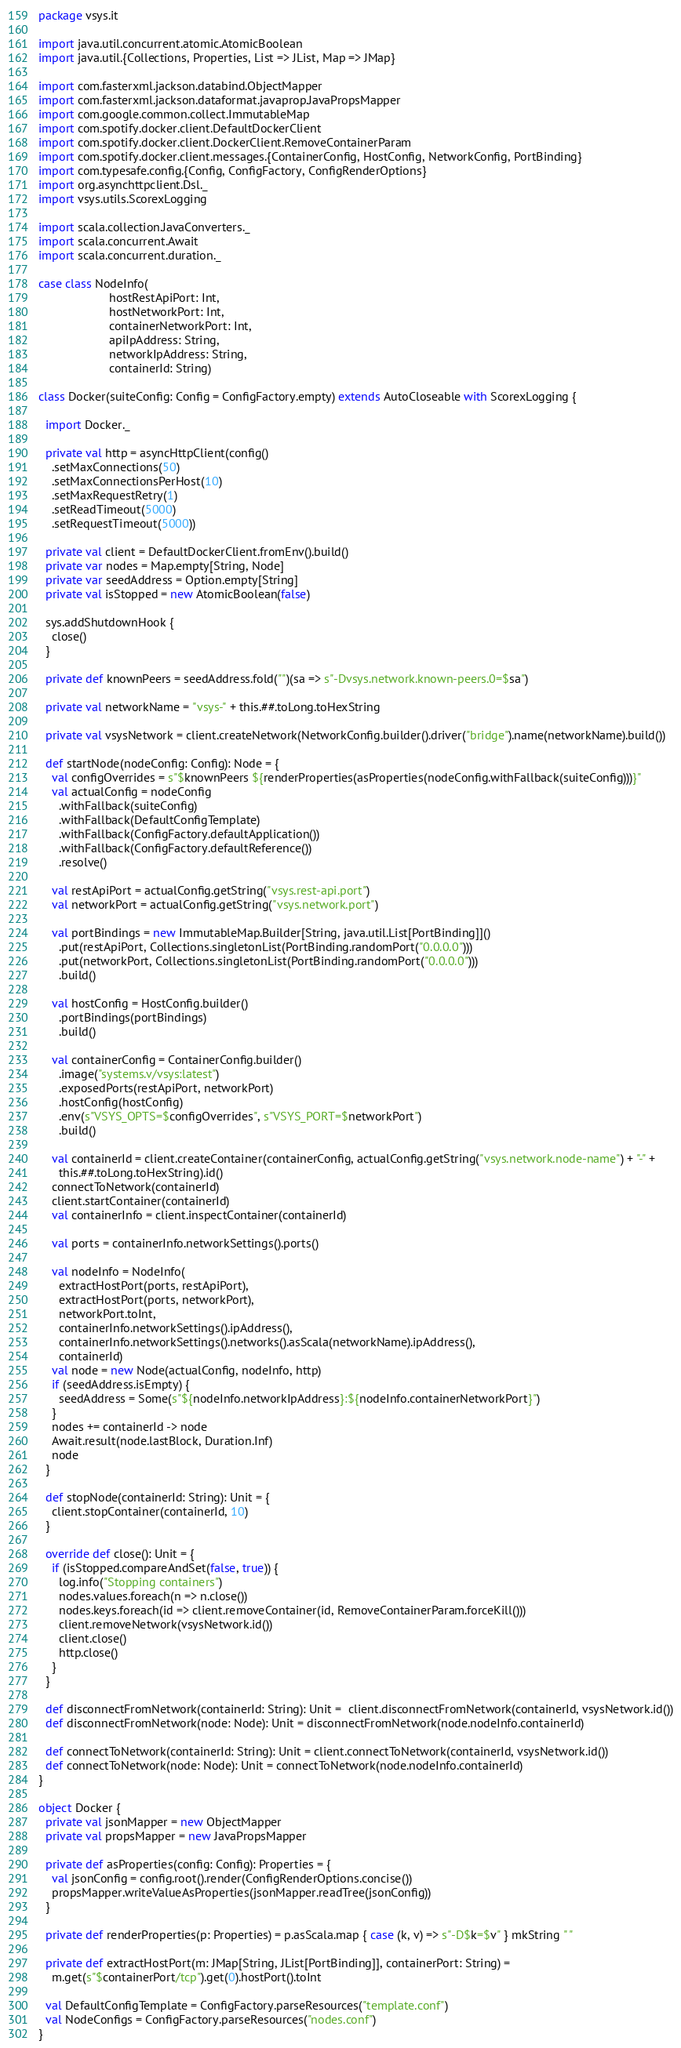Convert code to text. <code><loc_0><loc_0><loc_500><loc_500><_Scala_>package vsys.it

import java.util.concurrent.atomic.AtomicBoolean
import java.util.{Collections, Properties, List => JList, Map => JMap}

import com.fasterxml.jackson.databind.ObjectMapper
import com.fasterxml.jackson.dataformat.javaprop.JavaPropsMapper
import com.google.common.collect.ImmutableMap
import com.spotify.docker.client.DefaultDockerClient
import com.spotify.docker.client.DockerClient.RemoveContainerParam
import com.spotify.docker.client.messages.{ContainerConfig, HostConfig, NetworkConfig, PortBinding}
import com.typesafe.config.{Config, ConfigFactory, ConfigRenderOptions}
import org.asynchttpclient.Dsl._
import vsys.utils.ScorexLogging

import scala.collection.JavaConverters._
import scala.concurrent.Await
import scala.concurrent.duration._

case class NodeInfo(
                     hostRestApiPort: Int,
                     hostNetworkPort: Int,
                     containerNetworkPort: Int,
                     apiIpAddress: String,
                     networkIpAddress: String,
                     containerId: String)

class Docker(suiteConfig: Config = ConfigFactory.empty) extends AutoCloseable with ScorexLogging {

  import Docker._

  private val http = asyncHttpClient(config()
    .setMaxConnections(50)
    .setMaxConnectionsPerHost(10)
    .setMaxRequestRetry(1)
    .setReadTimeout(5000)
    .setRequestTimeout(5000))

  private val client = DefaultDockerClient.fromEnv().build()
  private var nodes = Map.empty[String, Node]
  private var seedAddress = Option.empty[String]
  private val isStopped = new AtomicBoolean(false)

  sys.addShutdownHook {
    close()
  }

  private def knownPeers = seedAddress.fold("")(sa => s"-Dvsys.network.known-peers.0=$sa")

  private val networkName = "vsys-" + this.##.toLong.toHexString

  private val vsysNetwork = client.createNetwork(NetworkConfig.builder().driver("bridge").name(networkName).build())

  def startNode(nodeConfig: Config): Node = {
    val configOverrides = s"$knownPeers ${renderProperties(asProperties(nodeConfig.withFallback(suiteConfig)))}"
    val actualConfig = nodeConfig
      .withFallback(suiteConfig)
      .withFallback(DefaultConfigTemplate)
      .withFallback(ConfigFactory.defaultApplication())
      .withFallback(ConfigFactory.defaultReference())
      .resolve()

    val restApiPort = actualConfig.getString("vsys.rest-api.port")
    val networkPort = actualConfig.getString("vsys.network.port")

    val portBindings = new ImmutableMap.Builder[String, java.util.List[PortBinding]]()
      .put(restApiPort, Collections.singletonList(PortBinding.randomPort("0.0.0.0")))
      .put(networkPort, Collections.singletonList(PortBinding.randomPort("0.0.0.0")))
      .build()

    val hostConfig = HostConfig.builder()
      .portBindings(portBindings)
      .build()

    val containerConfig = ContainerConfig.builder()
      .image("systems.v/vsys:latest")
      .exposedPorts(restApiPort, networkPort)
      .hostConfig(hostConfig)
      .env(s"VSYS_OPTS=$configOverrides", s"VSYS_PORT=$networkPort")
      .build()

    val containerId = client.createContainer(containerConfig, actualConfig.getString("vsys.network.node-name") + "-" +
      this.##.toLong.toHexString).id()
    connectToNetwork(containerId)
    client.startContainer(containerId)
    val containerInfo = client.inspectContainer(containerId)

    val ports = containerInfo.networkSettings().ports()

    val nodeInfo = NodeInfo(
      extractHostPort(ports, restApiPort),
      extractHostPort(ports, networkPort),
      networkPort.toInt,
      containerInfo.networkSettings().ipAddress(),
      containerInfo.networkSettings().networks().asScala(networkName).ipAddress(),
      containerId)
    val node = new Node(actualConfig, nodeInfo, http)
    if (seedAddress.isEmpty) {
      seedAddress = Some(s"${nodeInfo.networkIpAddress}:${nodeInfo.containerNetworkPort}")
    }
    nodes += containerId -> node
    Await.result(node.lastBlock, Duration.Inf)
    node
  }

  def stopNode(containerId: String): Unit = {
    client.stopContainer(containerId, 10)
  }

  override def close(): Unit = {
    if (isStopped.compareAndSet(false, true)) {
      log.info("Stopping containers")
      nodes.values.foreach(n => n.close())
      nodes.keys.foreach(id => client.removeContainer(id, RemoveContainerParam.forceKill()))
      client.removeNetwork(vsysNetwork.id())
      client.close()
      http.close()
    }
  }

  def disconnectFromNetwork(containerId: String): Unit =  client.disconnectFromNetwork(containerId, vsysNetwork.id())
  def disconnectFromNetwork(node: Node): Unit = disconnectFromNetwork(node.nodeInfo.containerId)

  def connectToNetwork(containerId: String): Unit = client.connectToNetwork(containerId, vsysNetwork.id())
  def connectToNetwork(node: Node): Unit = connectToNetwork(node.nodeInfo.containerId)
}

object Docker {
  private val jsonMapper = new ObjectMapper
  private val propsMapper = new JavaPropsMapper

  private def asProperties(config: Config): Properties = {
    val jsonConfig = config.root().render(ConfigRenderOptions.concise())
    propsMapper.writeValueAsProperties(jsonMapper.readTree(jsonConfig))
  }

  private def renderProperties(p: Properties) = p.asScala.map { case (k, v) => s"-D$k=$v" } mkString " "

  private def extractHostPort(m: JMap[String, JList[PortBinding]], containerPort: String) =
    m.get(s"$containerPort/tcp").get(0).hostPort().toInt

  val DefaultConfigTemplate = ConfigFactory.parseResources("template.conf")
  val NodeConfigs = ConfigFactory.parseResources("nodes.conf")
}
</code> 